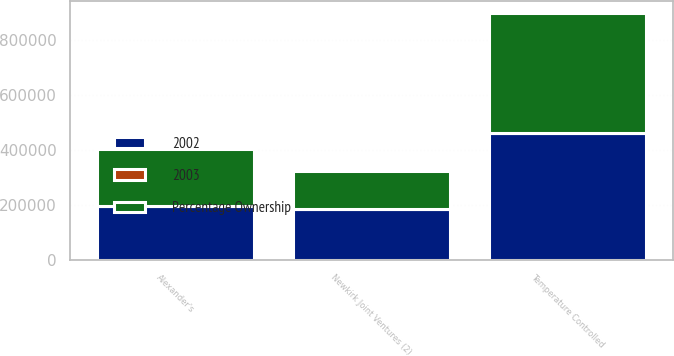Convert chart. <chart><loc_0><loc_0><loc_500><loc_500><stacked_bar_chart><ecel><fcel>Temperature Controlled<fcel>Alexander's<fcel>Newkirk Joint Ventures (2)<nl><fcel>2003<fcel>60<fcel>33.1<fcel>22.6<nl><fcel>Percentage Ownership<fcel>436225<fcel>207872<fcel>138762<nl><fcel>2002<fcel>459559<fcel>193879<fcel>182465<nl></chart> 